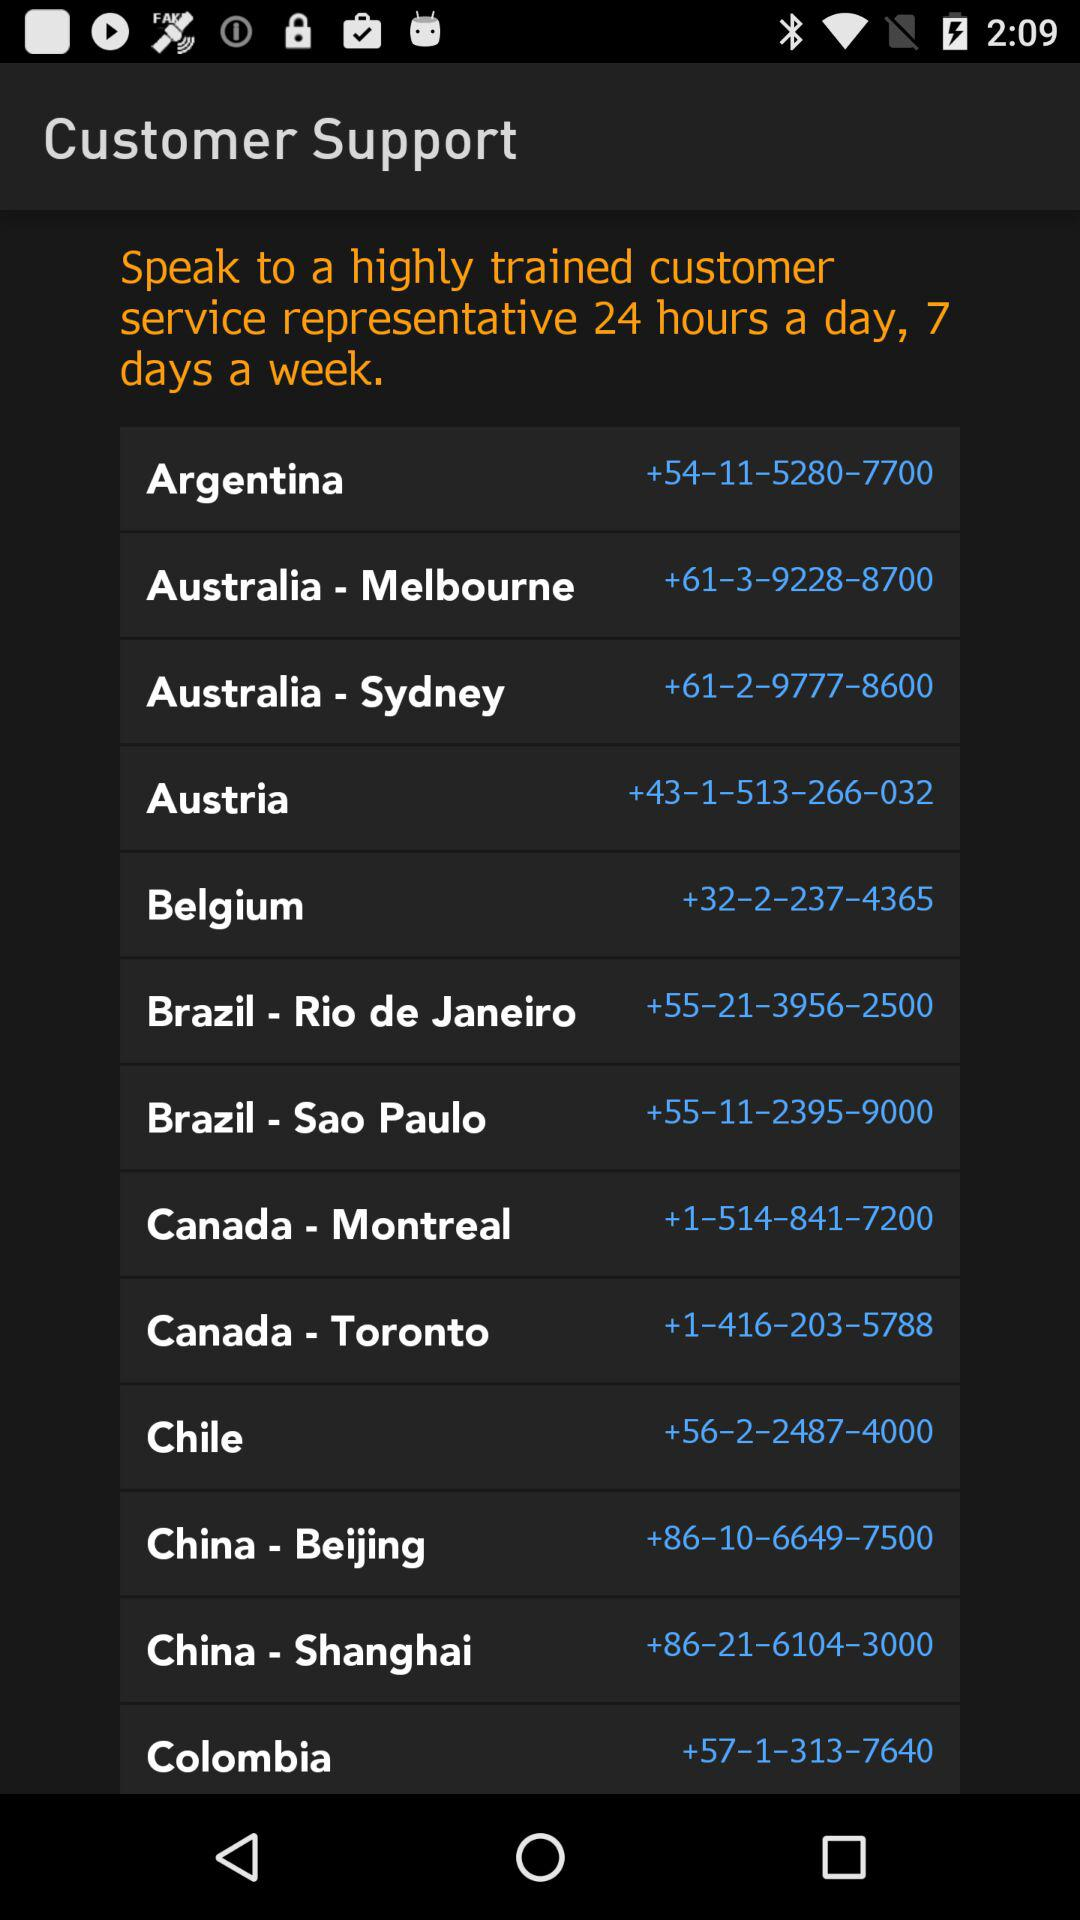For how many days of the week is the trained customer service representative available? The trained customer service representative is available 7 days a week. 